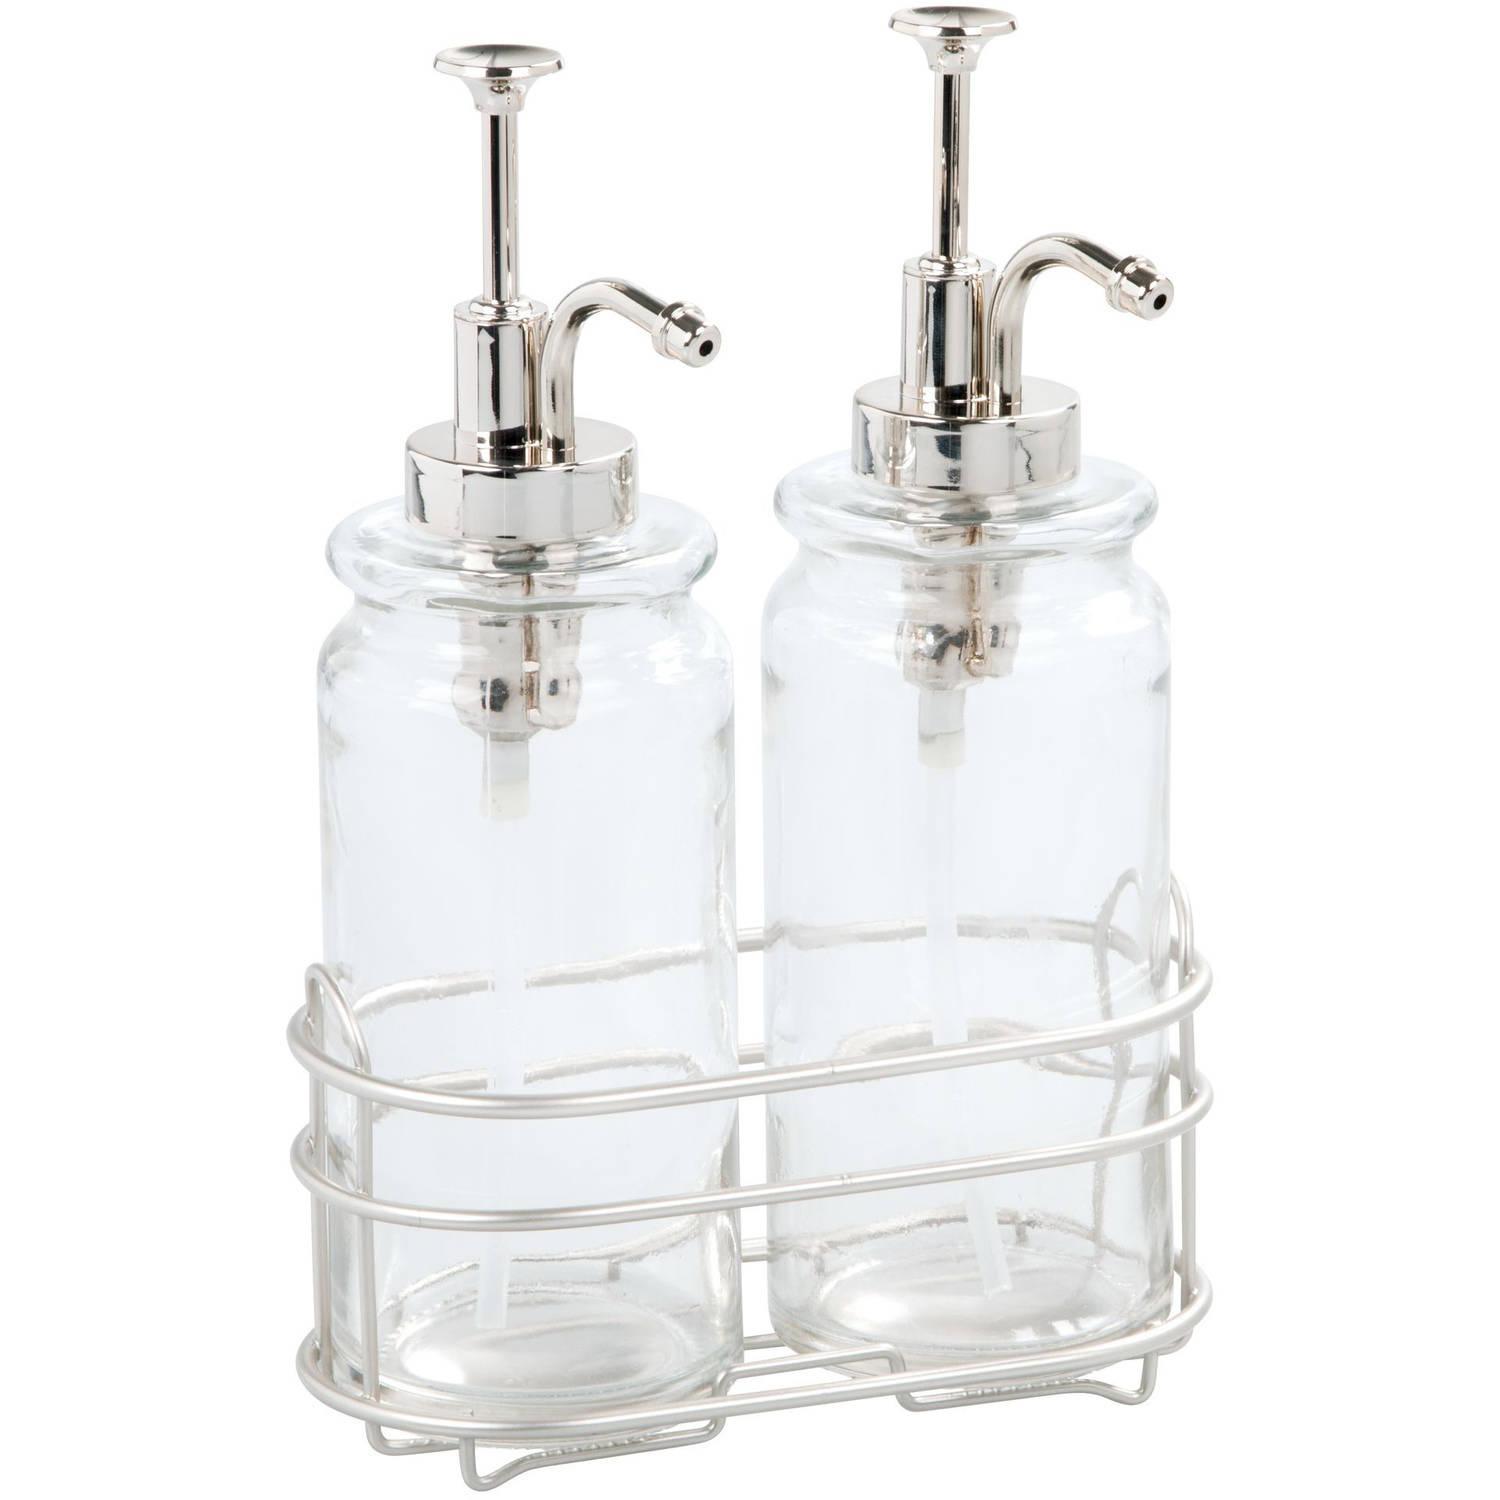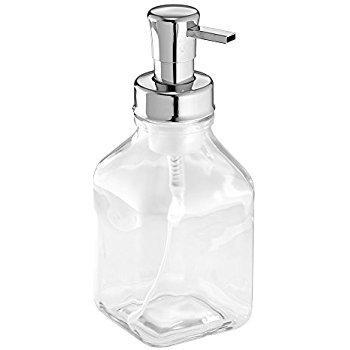The first image is the image on the left, the second image is the image on the right. Given the left and right images, does the statement "There are exactly two clear dispensers, one in each image." hold true? Answer yes or no. No. The first image is the image on the left, the second image is the image on the right. Analyze the images presented: Is the assertion "The left image features a caddy that holds two dispenser bottles side-by-side, and their pump nozzles face right." valid? Answer yes or no. Yes. 